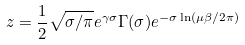<formula> <loc_0><loc_0><loc_500><loc_500>z = \frac { 1 } { 2 } \sqrt { \sigma / \pi } e ^ { \gamma \sigma } \Gamma ( \sigma ) e ^ { - \sigma \ln ( \mu \beta / 2 \pi ) }</formula> 